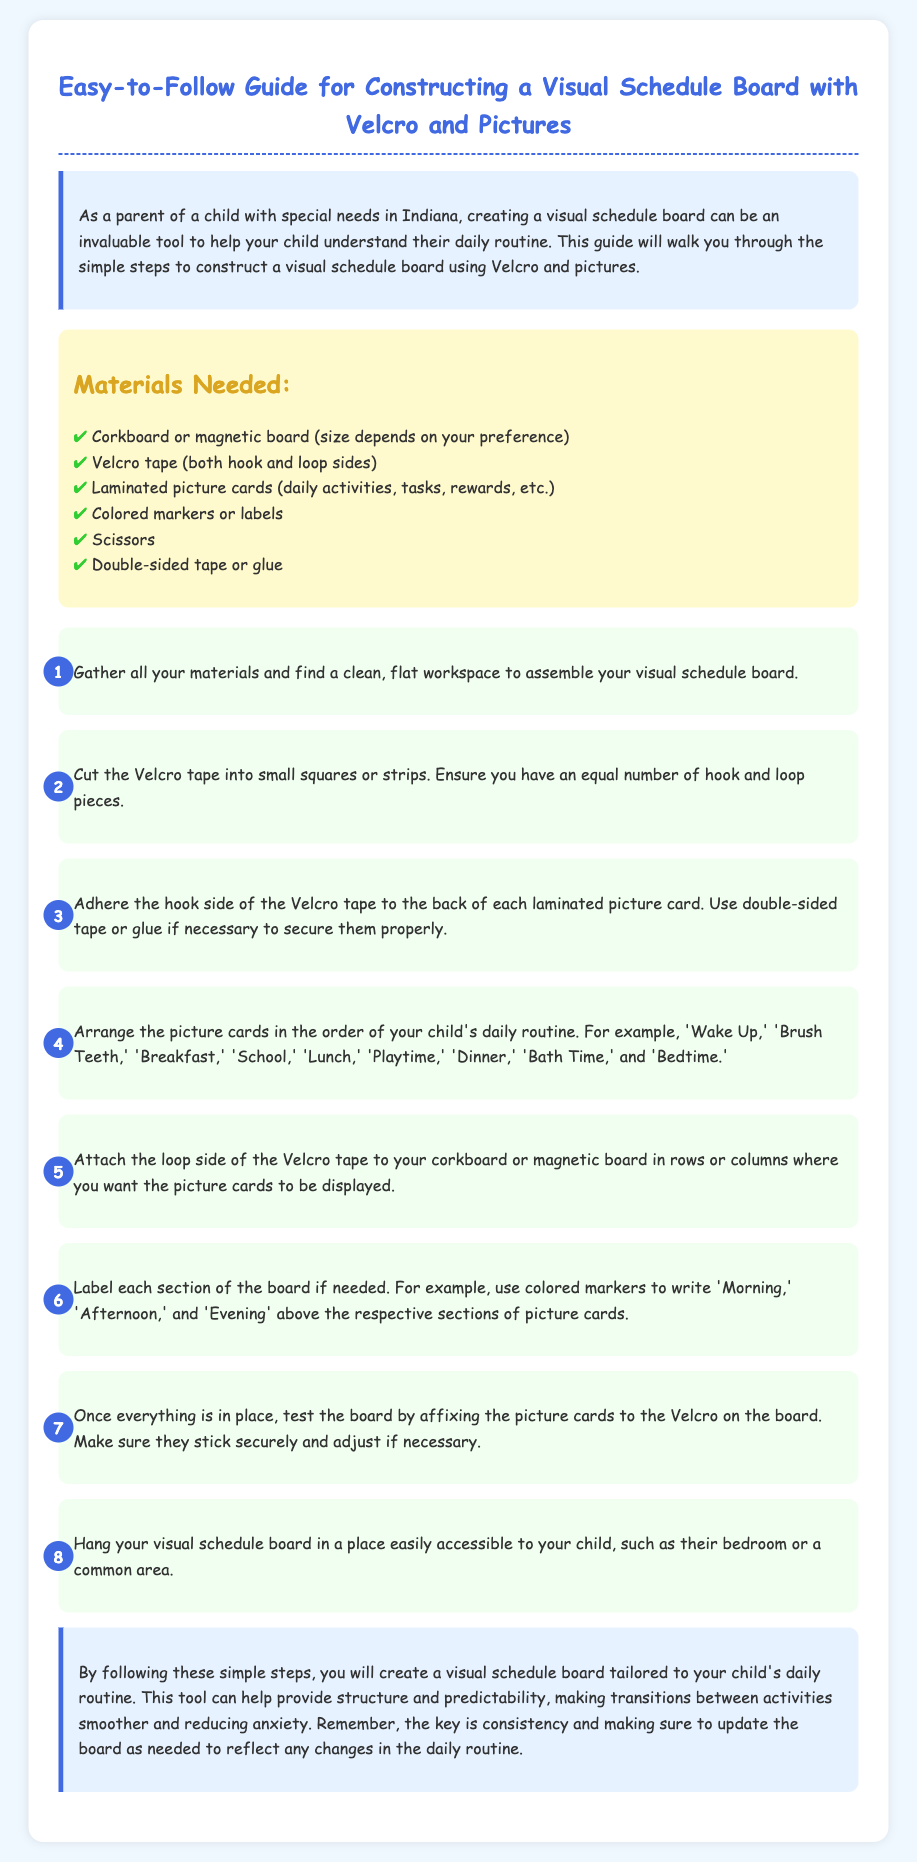What is the title of the document? The title is presented prominently at the top of the document, introducing the subject matter.
Answer: Easy-to-Follow Guide for Constructing a Visual Schedule Board with Velcro and Pictures How many materials are listed? The materials section includes a specific number of items needed for assembly.
Answer: Six What is the first step in the assembly instructions? The steps are listed in a sequential format, describing the initial action to take.
Answer: Gather all your materials and find a clean, flat workspace What is the main purpose of creating a visual schedule board? The introduction explains the significance of the schedule board for your child.
Answer: Help your child understand their daily routine What should you use to label the sections of the board? The document specifies a tool for adding labels to enhance clarity on the board.
Answer: Colored markers What must be ensured about the Velcro pieces? This information can be found in the step explaining how to prepare the Velcro for use.
Answer: Equal number of hook and loop pieces In what locations can the visual schedule board be hung? The last step discusses the appropriate placement for accessibility by the child.
Answer: Bedroom or a common area What is suggested to do with the board to reflect any changes? The conclusion advises on maintaining the board for continued relevance to the child's routine.
Answer: Update the board as needed 